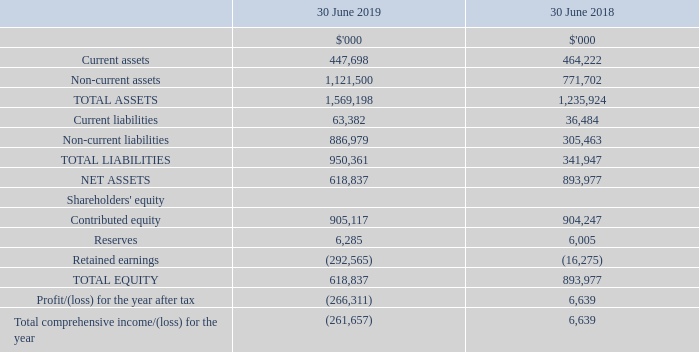28 Parent entity financial information
The individual financial statements for the parent entity show the following aggregate amounts:
NEXTDC Limited acquired Asia Pacific Data Centre (“APDC”) on 18 October 2018 (refer to note 26). Following acquisition, the entities comprising APDC were subsequently wound up, and the underlying properties were transferred to a new entity established by NEXTDC - NEXTDC Holdings Trust No. 1 (refer to note 27). This resulted in the above loss in the parent entity on derecognition of its investment in APDC, while a corresponding gain was recorded in NEXTDC Holdings Trust No. 1 on transfer of the properties.
(a) Reserves
Due to the requirements of accounting standards, the loan provided by NEXTDC Limited (parent entity) to NEXTDC Share Plan Pty Ltd requires the loan in respect of the loan funded share plan to be recorded as an issue of treasury shares and a corresponding debit to equity (treasury share reserve).
(b) Guarantees entered into by the parent entity in relation to the debts of its subsidiaries
As at 30 June 2019, NEXTDC Limited did not have any guarantees in relation to the debts of subsidiaries.
(c) Contingent liabilities of NEXTDC Limited (parent entity)
The parent entity did not have any contingent liabilities as at 30 June 2019 or 30 June 2018. For information about guarantees given by the parent entity, please see above.
(d) Contractual commitments by NEXTDC for the acquisition of property, plant and equipment
Contractual commitments detailed in Note 17 relate to NEXTDC Limited as parent entity.
(e) Determining the parent entity financial information
The financial information for the parent entity has been prepared on the same basis as the consolidated financial statements, except as set out below.
(i) Tax consolidation legislation
NEXTDC Limited and its wholly-owned Australian controlled entities have implemented the tax consolidation legislation.
The head entity, NEXTDC Limited, and the controlled entities in the tax consolidated Group account for their own current and deferred tax amounts. These tax amounts are measured as if each entity in the tax consolidated Group continues to be a stand-alone taxpayer in its own right.
In addition to its own current and deferred tax amounts, NEXTDC Limited also recognises the current tax liabilities (or assets) and the deferred tax assets arising from unused tax losses and unused tax credits assumed from controlled entities in the tax consolidated Group.
The entities have also entered into a tax funding agreement under which the wholly-owned entities fully compensate NEXTDC Limited for any current tax payable assumed and are compensated by NEXTDC Limited for any current tax receivable and deferred tax assets relating to unused tax losses or unused tax credits that are transferred to NEXTDC Limited under the tax consolidation legislation. The funding amounts are determined by reference to the amounts recognised in the wholly-owned entities’ financial statements.
The amounts receivable/payable under the tax funding agreement are due upon receipt of the funding advice from the head entity, which is issued as soon as practicable after the end of each financial year. The head entity may also require payment of interim funding amounts to assist with its obligations to pay tax instalments.
Assets or liabilities arising under tax funding agreements with the tax consolidated entities are recognised as current amounts receivable from or payable to other entities in the Group.
Any difference between the amounts assumed and amounts receivable or payable under the tax funding agreement are recognised as a contribution to (or distribution from) wholly-owned tax consolidated entities.
(ii) Investments in subsidiaries, associates and joint venture entities
Investments in subsidiaries are accounted for at cost in the financial statements of NEXTDC Limited.
Do the company have any guarantees in relation to the debts of subsidiaries as of June 30, 2019? Did not have any guarantees in relation to the debts of subsidiaries. How much was the total loss for 2019 after tax?
Answer scale should be: thousand. 266,311. How much was the total assets in 2018?
Answer scale should be: thousand. 1,235,924. What was the percentage change in total liabilities between 2018 and 2019?
Answer scale should be: percent. (950,361 - 341,947) / 341,947 
Answer: 177.93. What was the difference between current and non-current assets in 2018?
Answer scale should be: thousand. 771,702 - 464,222 
Answer: 307480. What was the percentage change in reserves between 2018 and 2019?
Answer scale should be: percent. (6,285 - 6,005) / 6,005 
Answer: 4.66. 